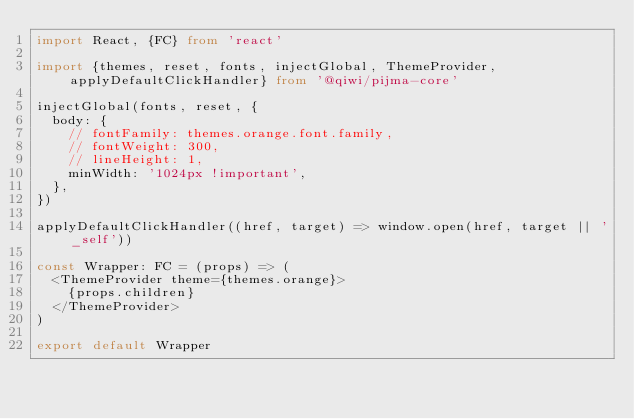Convert code to text. <code><loc_0><loc_0><loc_500><loc_500><_TypeScript_>import React, {FC} from 'react'

import {themes, reset, fonts, injectGlobal, ThemeProvider, applyDefaultClickHandler} from '@qiwi/pijma-core'

injectGlobal(fonts, reset, {
  body: {
    // fontFamily: themes.orange.font.family,
    // fontWeight: 300,
    // lineHeight: 1,
    minWidth: '1024px !important',
  },
})

applyDefaultClickHandler((href, target) => window.open(href, target || '_self'))

const Wrapper: FC = (props) => (
  <ThemeProvider theme={themes.orange}>
    {props.children}
  </ThemeProvider>
)

export default Wrapper
</code> 